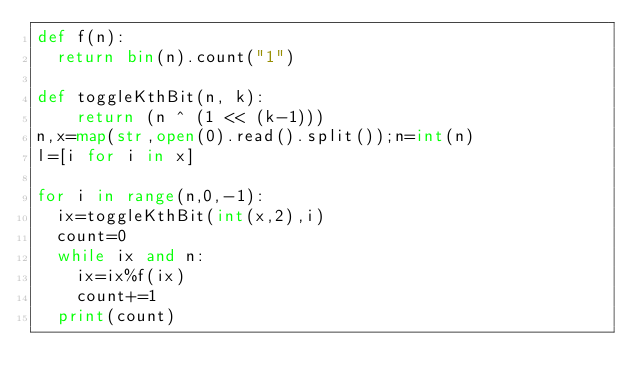Convert code to text. <code><loc_0><loc_0><loc_500><loc_500><_Python_>def f(n):
  return bin(n).count("1")

def toggleKthBit(n, k): 
    return (n ^ (1 << (k-1))) 
n,x=map(str,open(0).read().split());n=int(n)
l=[i for i in x]

for i in range(n,0,-1):
  ix=toggleKthBit(int(x,2),i)
  count=0
  while ix and n:
    ix=ix%f(ix)
    count+=1
  print(count)</code> 